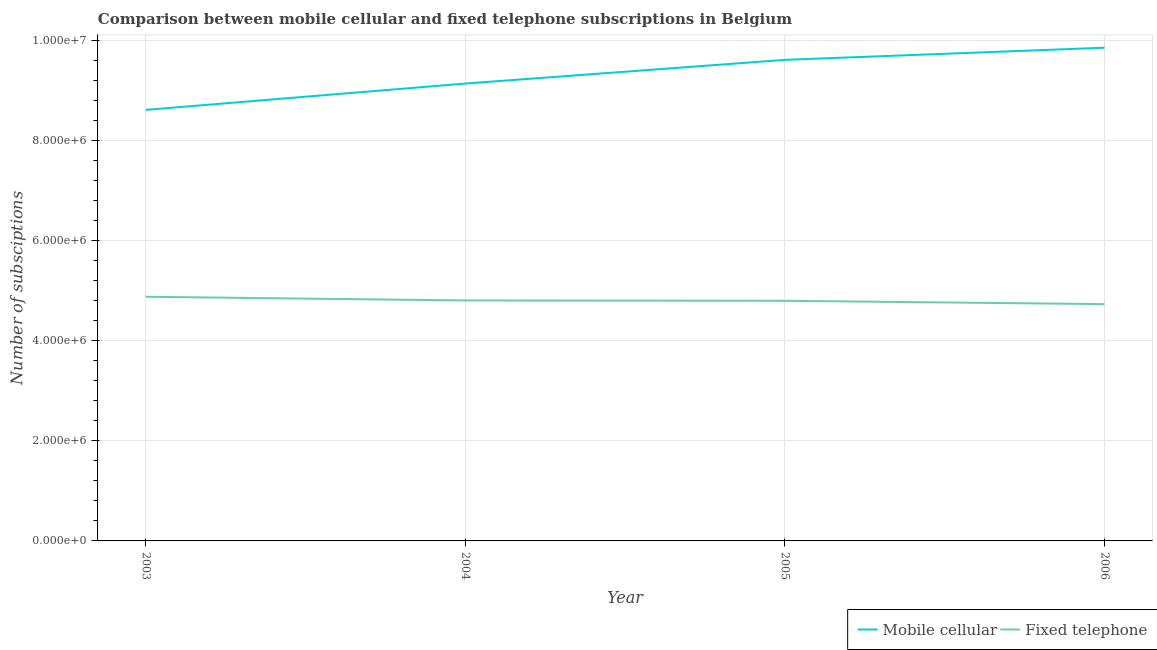How many different coloured lines are there?
Your answer should be compact. 2. Does the line corresponding to number of mobile cellular subscriptions intersect with the line corresponding to number of fixed telephone subscriptions?
Offer a very short reply. No. What is the number of fixed telephone subscriptions in 2003?
Offer a terse response. 4.88e+06. Across all years, what is the maximum number of mobile cellular subscriptions?
Ensure brevity in your answer.  9.85e+06. Across all years, what is the minimum number of fixed telephone subscriptions?
Provide a short and direct response. 4.73e+06. In which year was the number of fixed telephone subscriptions maximum?
Keep it short and to the point. 2003. In which year was the number of mobile cellular subscriptions minimum?
Your response must be concise. 2003. What is the total number of mobile cellular subscriptions in the graph?
Ensure brevity in your answer.  3.72e+07. What is the difference between the number of fixed telephone subscriptions in 2003 and that in 2004?
Provide a succinct answer. 7.40e+04. What is the difference between the number of fixed telephone subscriptions in 2004 and the number of mobile cellular subscriptions in 2006?
Your answer should be compact. -5.05e+06. What is the average number of mobile cellular subscriptions per year?
Offer a very short reply. 9.30e+06. In the year 2003, what is the difference between the number of mobile cellular subscriptions and number of fixed telephone subscriptions?
Your answer should be very brief. 3.73e+06. What is the ratio of the number of fixed telephone subscriptions in 2003 to that in 2005?
Your response must be concise. 1.02. Is the number of mobile cellular subscriptions in 2003 less than that in 2006?
Make the answer very short. Yes. What is the difference between the highest and the second highest number of fixed telephone subscriptions?
Offer a terse response. 7.40e+04. What is the difference between the highest and the lowest number of mobile cellular subscriptions?
Ensure brevity in your answer.  1.24e+06. Does the number of fixed telephone subscriptions monotonically increase over the years?
Ensure brevity in your answer.  No. Is the number of mobile cellular subscriptions strictly greater than the number of fixed telephone subscriptions over the years?
Offer a terse response. Yes. Is the number of mobile cellular subscriptions strictly less than the number of fixed telephone subscriptions over the years?
Your answer should be compact. No. How many lines are there?
Keep it short and to the point. 2. How many years are there in the graph?
Make the answer very short. 4. What is the difference between two consecutive major ticks on the Y-axis?
Give a very brief answer. 2.00e+06. Are the values on the major ticks of Y-axis written in scientific E-notation?
Your answer should be compact. Yes. Does the graph contain any zero values?
Offer a terse response. No. Does the graph contain grids?
Offer a terse response. Yes. What is the title of the graph?
Ensure brevity in your answer.  Comparison between mobile cellular and fixed telephone subscriptions in Belgium. Does "Overweight" appear as one of the legend labels in the graph?
Offer a terse response. No. What is the label or title of the Y-axis?
Your answer should be very brief. Number of subsciptions. What is the Number of subsciptions of Mobile cellular in 2003?
Ensure brevity in your answer.  8.61e+06. What is the Number of subsciptions of Fixed telephone in 2003?
Provide a succinct answer. 4.88e+06. What is the Number of subsciptions of Mobile cellular in 2004?
Ensure brevity in your answer.  9.13e+06. What is the Number of subsciptions in Fixed telephone in 2004?
Give a very brief answer. 4.80e+06. What is the Number of subsciptions of Mobile cellular in 2005?
Provide a succinct answer. 9.60e+06. What is the Number of subsciptions in Fixed telephone in 2005?
Your answer should be compact. 4.79e+06. What is the Number of subsciptions in Mobile cellular in 2006?
Offer a very short reply. 9.85e+06. What is the Number of subsciptions of Fixed telephone in 2006?
Make the answer very short. 4.73e+06. Across all years, what is the maximum Number of subsciptions in Mobile cellular?
Keep it short and to the point. 9.85e+06. Across all years, what is the maximum Number of subsciptions of Fixed telephone?
Your answer should be very brief. 4.88e+06. Across all years, what is the minimum Number of subsciptions of Mobile cellular?
Your answer should be very brief. 8.61e+06. Across all years, what is the minimum Number of subsciptions in Fixed telephone?
Make the answer very short. 4.73e+06. What is the total Number of subsciptions of Mobile cellular in the graph?
Make the answer very short. 3.72e+07. What is the total Number of subsciptions in Fixed telephone in the graph?
Your answer should be compact. 1.92e+07. What is the difference between the Number of subsciptions in Mobile cellular in 2003 and that in 2004?
Offer a terse response. -5.26e+05. What is the difference between the Number of subsciptions in Fixed telephone in 2003 and that in 2004?
Your response must be concise. 7.40e+04. What is the difference between the Number of subsciptions of Mobile cellular in 2003 and that in 2005?
Ensure brevity in your answer.  -9.99e+05. What is the difference between the Number of subsciptions of Fixed telephone in 2003 and that in 2005?
Keep it short and to the point. 8.04e+04. What is the difference between the Number of subsciptions of Mobile cellular in 2003 and that in 2006?
Your response must be concise. -1.24e+06. What is the difference between the Number of subsciptions in Fixed telephone in 2003 and that in 2006?
Provide a succinct answer. 1.47e+05. What is the difference between the Number of subsciptions of Mobile cellular in 2004 and that in 2005?
Your answer should be very brief. -4.73e+05. What is the difference between the Number of subsciptions of Fixed telephone in 2004 and that in 2005?
Make the answer very short. 6417. What is the difference between the Number of subsciptions of Mobile cellular in 2004 and that in 2006?
Ensure brevity in your answer.  -7.16e+05. What is the difference between the Number of subsciptions of Fixed telephone in 2004 and that in 2006?
Ensure brevity in your answer.  7.32e+04. What is the difference between the Number of subsciptions of Mobile cellular in 2005 and that in 2006?
Your answer should be compact. -2.43e+05. What is the difference between the Number of subsciptions of Fixed telephone in 2005 and that in 2006?
Offer a very short reply. 6.68e+04. What is the difference between the Number of subsciptions of Mobile cellular in 2003 and the Number of subsciptions of Fixed telephone in 2004?
Your answer should be very brief. 3.80e+06. What is the difference between the Number of subsciptions of Mobile cellular in 2003 and the Number of subsciptions of Fixed telephone in 2005?
Provide a succinct answer. 3.81e+06. What is the difference between the Number of subsciptions in Mobile cellular in 2003 and the Number of subsciptions in Fixed telephone in 2006?
Provide a short and direct response. 3.88e+06. What is the difference between the Number of subsciptions of Mobile cellular in 2004 and the Number of subsciptions of Fixed telephone in 2005?
Provide a short and direct response. 4.34e+06. What is the difference between the Number of subsciptions of Mobile cellular in 2004 and the Number of subsciptions of Fixed telephone in 2006?
Keep it short and to the point. 4.40e+06. What is the difference between the Number of subsciptions in Mobile cellular in 2005 and the Number of subsciptions in Fixed telephone in 2006?
Keep it short and to the point. 4.88e+06. What is the average Number of subsciptions of Mobile cellular per year?
Give a very brief answer. 9.30e+06. What is the average Number of subsciptions in Fixed telephone per year?
Your answer should be very brief. 4.80e+06. In the year 2003, what is the difference between the Number of subsciptions in Mobile cellular and Number of subsciptions in Fixed telephone?
Your answer should be compact. 3.73e+06. In the year 2004, what is the difference between the Number of subsciptions in Mobile cellular and Number of subsciptions in Fixed telephone?
Your response must be concise. 4.33e+06. In the year 2005, what is the difference between the Number of subsciptions in Mobile cellular and Number of subsciptions in Fixed telephone?
Offer a terse response. 4.81e+06. In the year 2006, what is the difference between the Number of subsciptions in Mobile cellular and Number of subsciptions in Fixed telephone?
Ensure brevity in your answer.  5.12e+06. What is the ratio of the Number of subsciptions of Mobile cellular in 2003 to that in 2004?
Your response must be concise. 0.94. What is the ratio of the Number of subsciptions of Fixed telephone in 2003 to that in 2004?
Your answer should be compact. 1.02. What is the ratio of the Number of subsciptions of Mobile cellular in 2003 to that in 2005?
Keep it short and to the point. 0.9. What is the ratio of the Number of subsciptions in Fixed telephone in 2003 to that in 2005?
Offer a terse response. 1.02. What is the ratio of the Number of subsciptions in Mobile cellular in 2003 to that in 2006?
Provide a succinct answer. 0.87. What is the ratio of the Number of subsciptions in Fixed telephone in 2003 to that in 2006?
Provide a succinct answer. 1.03. What is the ratio of the Number of subsciptions of Mobile cellular in 2004 to that in 2005?
Ensure brevity in your answer.  0.95. What is the ratio of the Number of subsciptions of Fixed telephone in 2004 to that in 2005?
Offer a very short reply. 1. What is the ratio of the Number of subsciptions of Mobile cellular in 2004 to that in 2006?
Make the answer very short. 0.93. What is the ratio of the Number of subsciptions of Fixed telephone in 2004 to that in 2006?
Your answer should be compact. 1.02. What is the ratio of the Number of subsciptions in Mobile cellular in 2005 to that in 2006?
Your response must be concise. 0.98. What is the ratio of the Number of subsciptions of Fixed telephone in 2005 to that in 2006?
Ensure brevity in your answer.  1.01. What is the difference between the highest and the second highest Number of subsciptions in Mobile cellular?
Your answer should be very brief. 2.43e+05. What is the difference between the highest and the second highest Number of subsciptions in Fixed telephone?
Provide a short and direct response. 7.40e+04. What is the difference between the highest and the lowest Number of subsciptions in Mobile cellular?
Give a very brief answer. 1.24e+06. What is the difference between the highest and the lowest Number of subsciptions in Fixed telephone?
Offer a very short reply. 1.47e+05. 